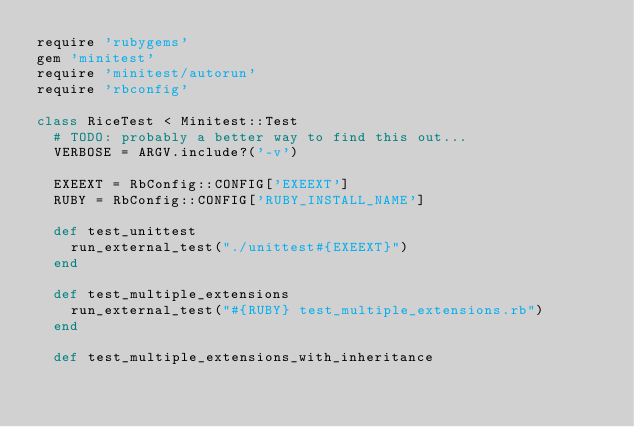Convert code to text. <code><loc_0><loc_0><loc_500><loc_500><_Ruby_>require 'rubygems'
gem 'minitest'
require 'minitest/autorun'
require 'rbconfig'

class RiceTest < Minitest::Test
  # TODO: probably a better way to find this out...
  VERBOSE = ARGV.include?('-v')

  EXEEXT = RbConfig::CONFIG['EXEEXT']
  RUBY = RbConfig::CONFIG['RUBY_INSTALL_NAME']

  def test_unittest
    run_external_test("./unittest#{EXEEXT}")
  end

  def test_multiple_extensions
    run_external_test("#{RUBY} test_multiple_extensions.rb")
  end

  def test_multiple_extensions_with_inheritance</code> 